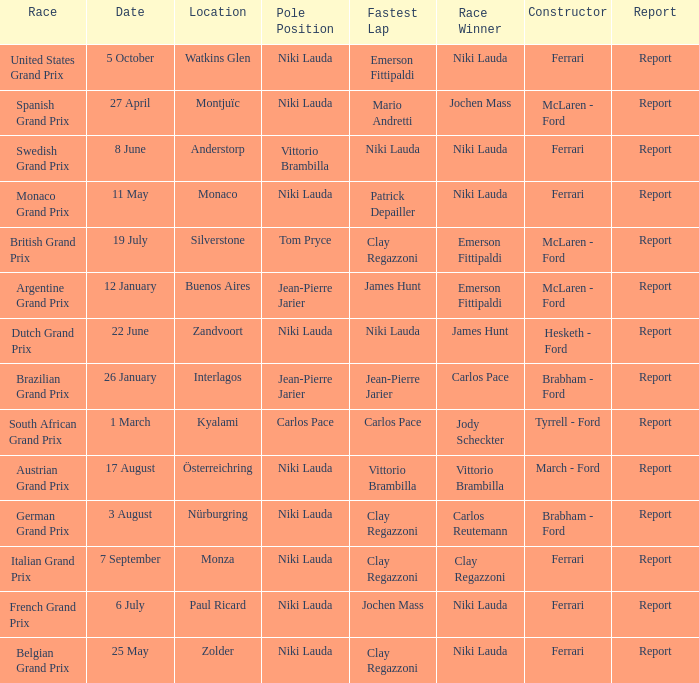Who ran the fastest lap in the team that competed in Zolder, in which Ferrari was the Constructor? Clay Regazzoni. 